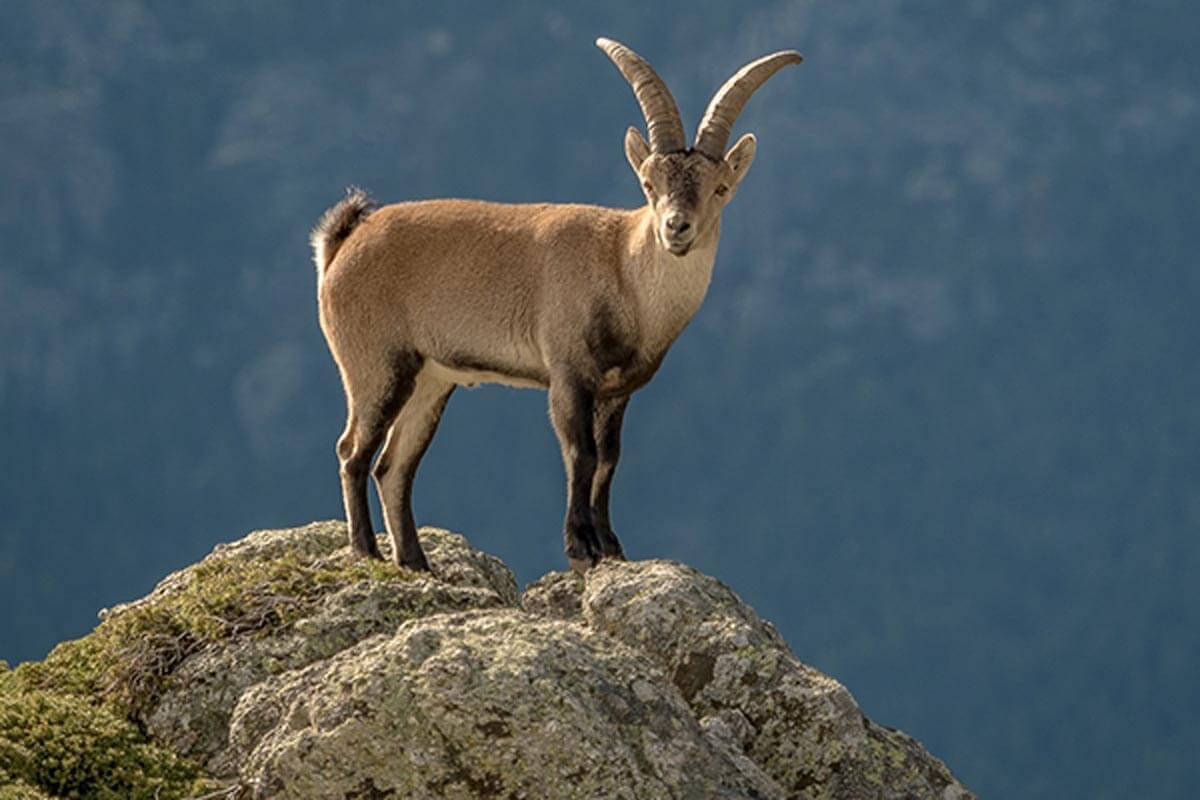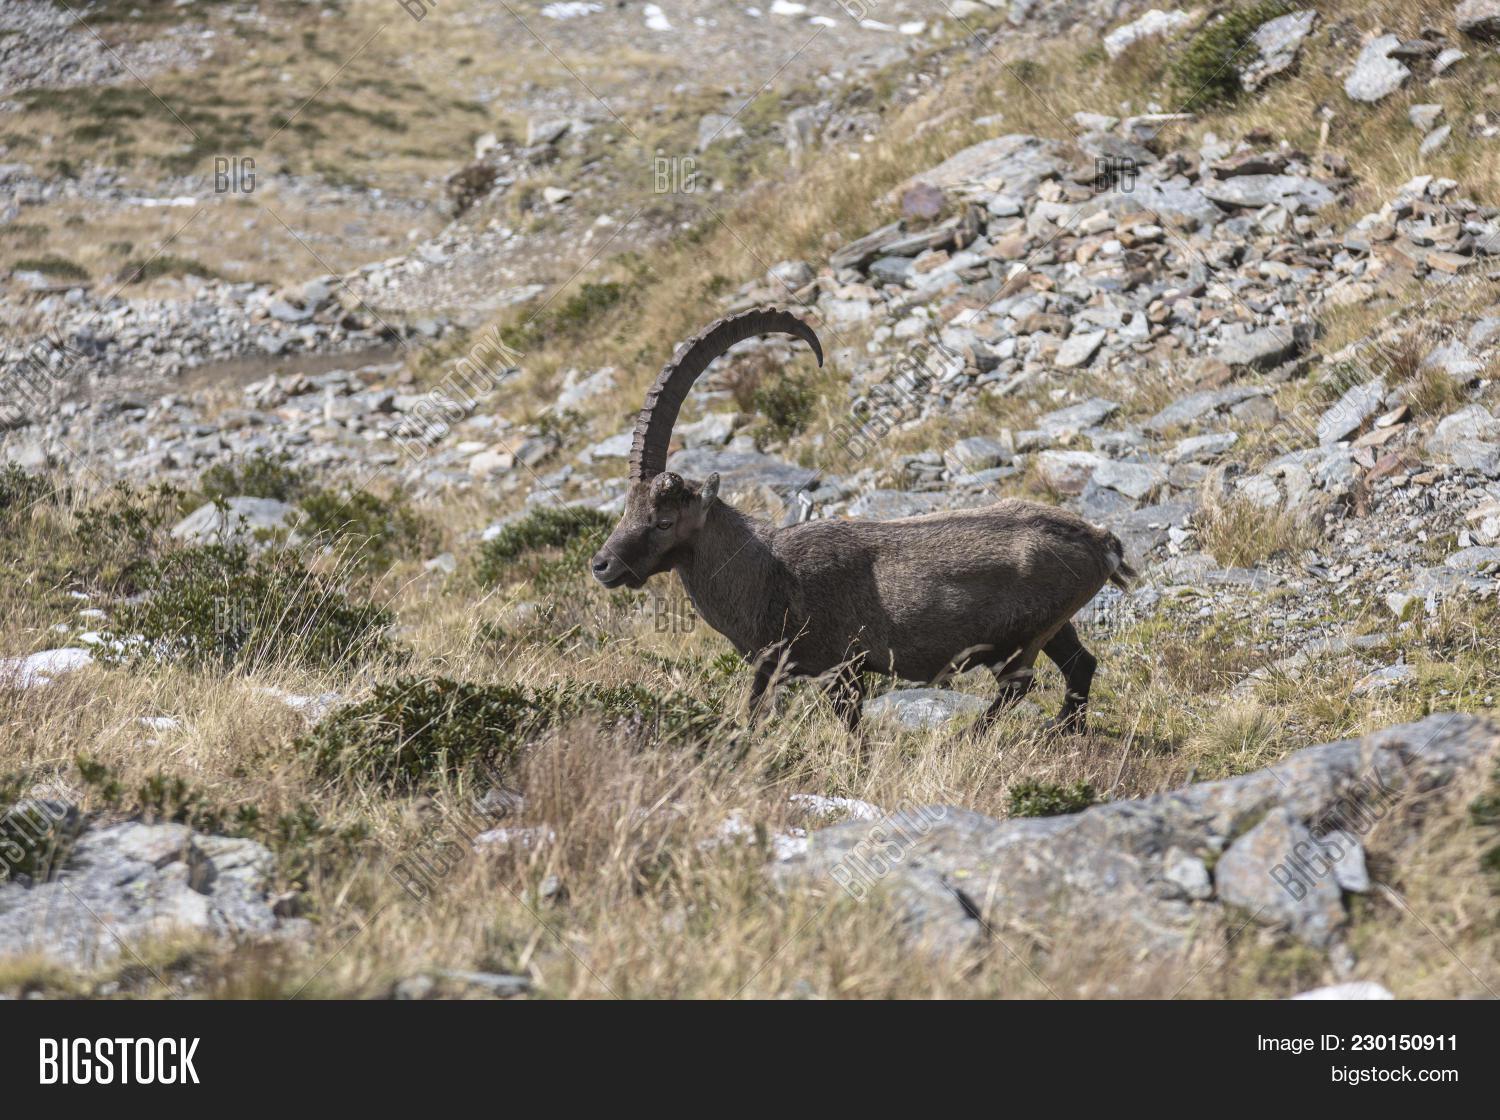The first image is the image on the left, the second image is the image on the right. Examine the images to the left and right. Is the description "The left and right image contains the same number of goats." accurate? Answer yes or no. Yes. The first image is the image on the left, the second image is the image on the right. Considering the images on both sides, is "One image contains one horned animal with its head in profile facing right, and the other image includes two hooved animals." valid? Answer yes or no. No. 